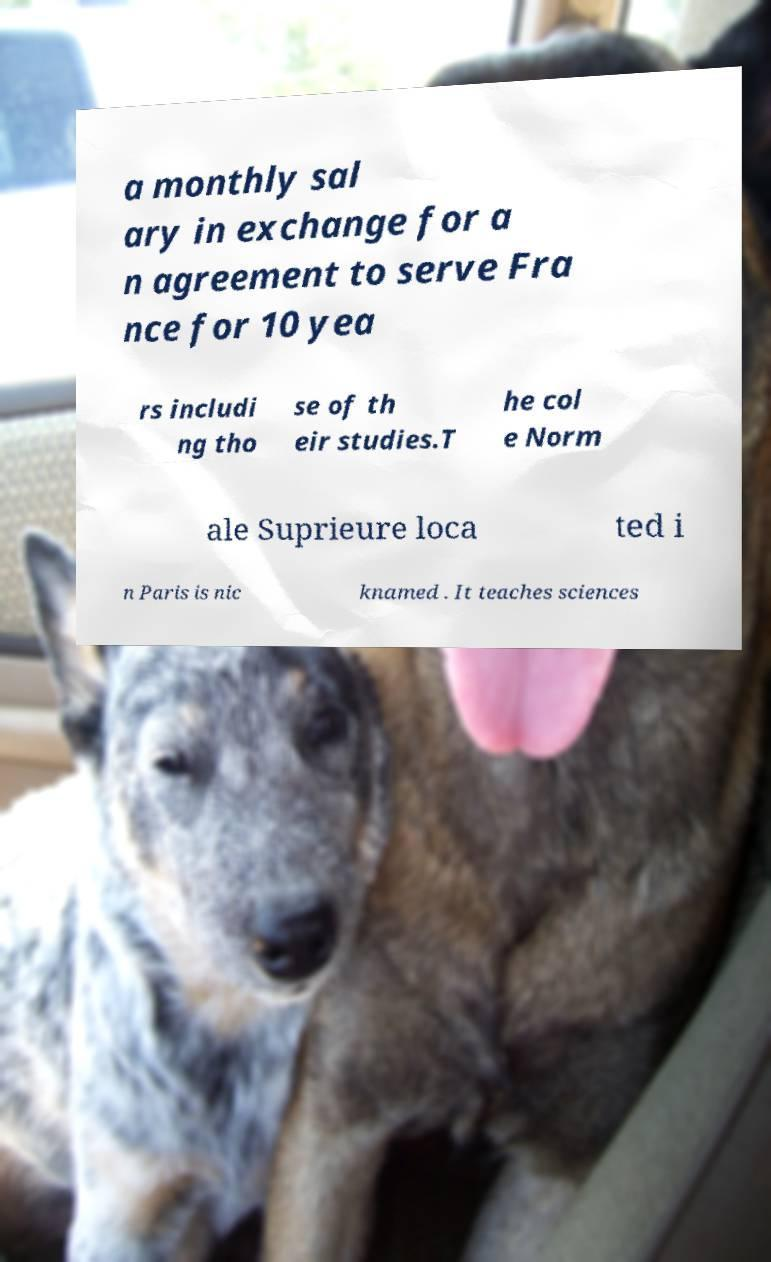I need the written content from this picture converted into text. Can you do that? a monthly sal ary in exchange for a n agreement to serve Fra nce for 10 yea rs includi ng tho se of th eir studies.T he col e Norm ale Suprieure loca ted i n Paris is nic knamed . It teaches sciences 